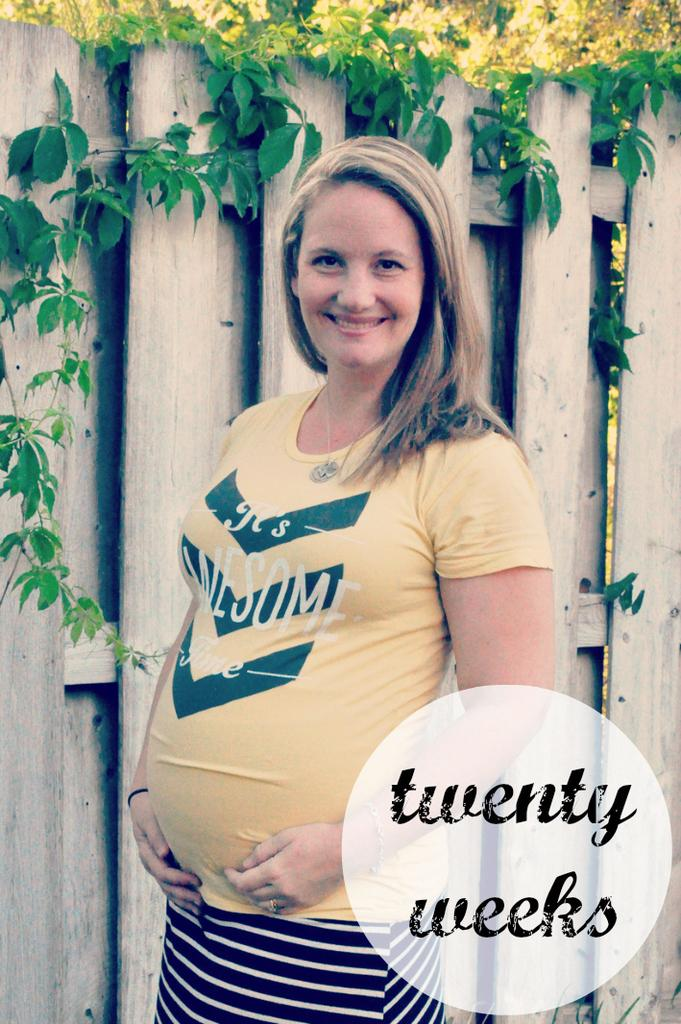<image>
Describe the image concisely. The sign tells how many weeks pregnant the woman is. 